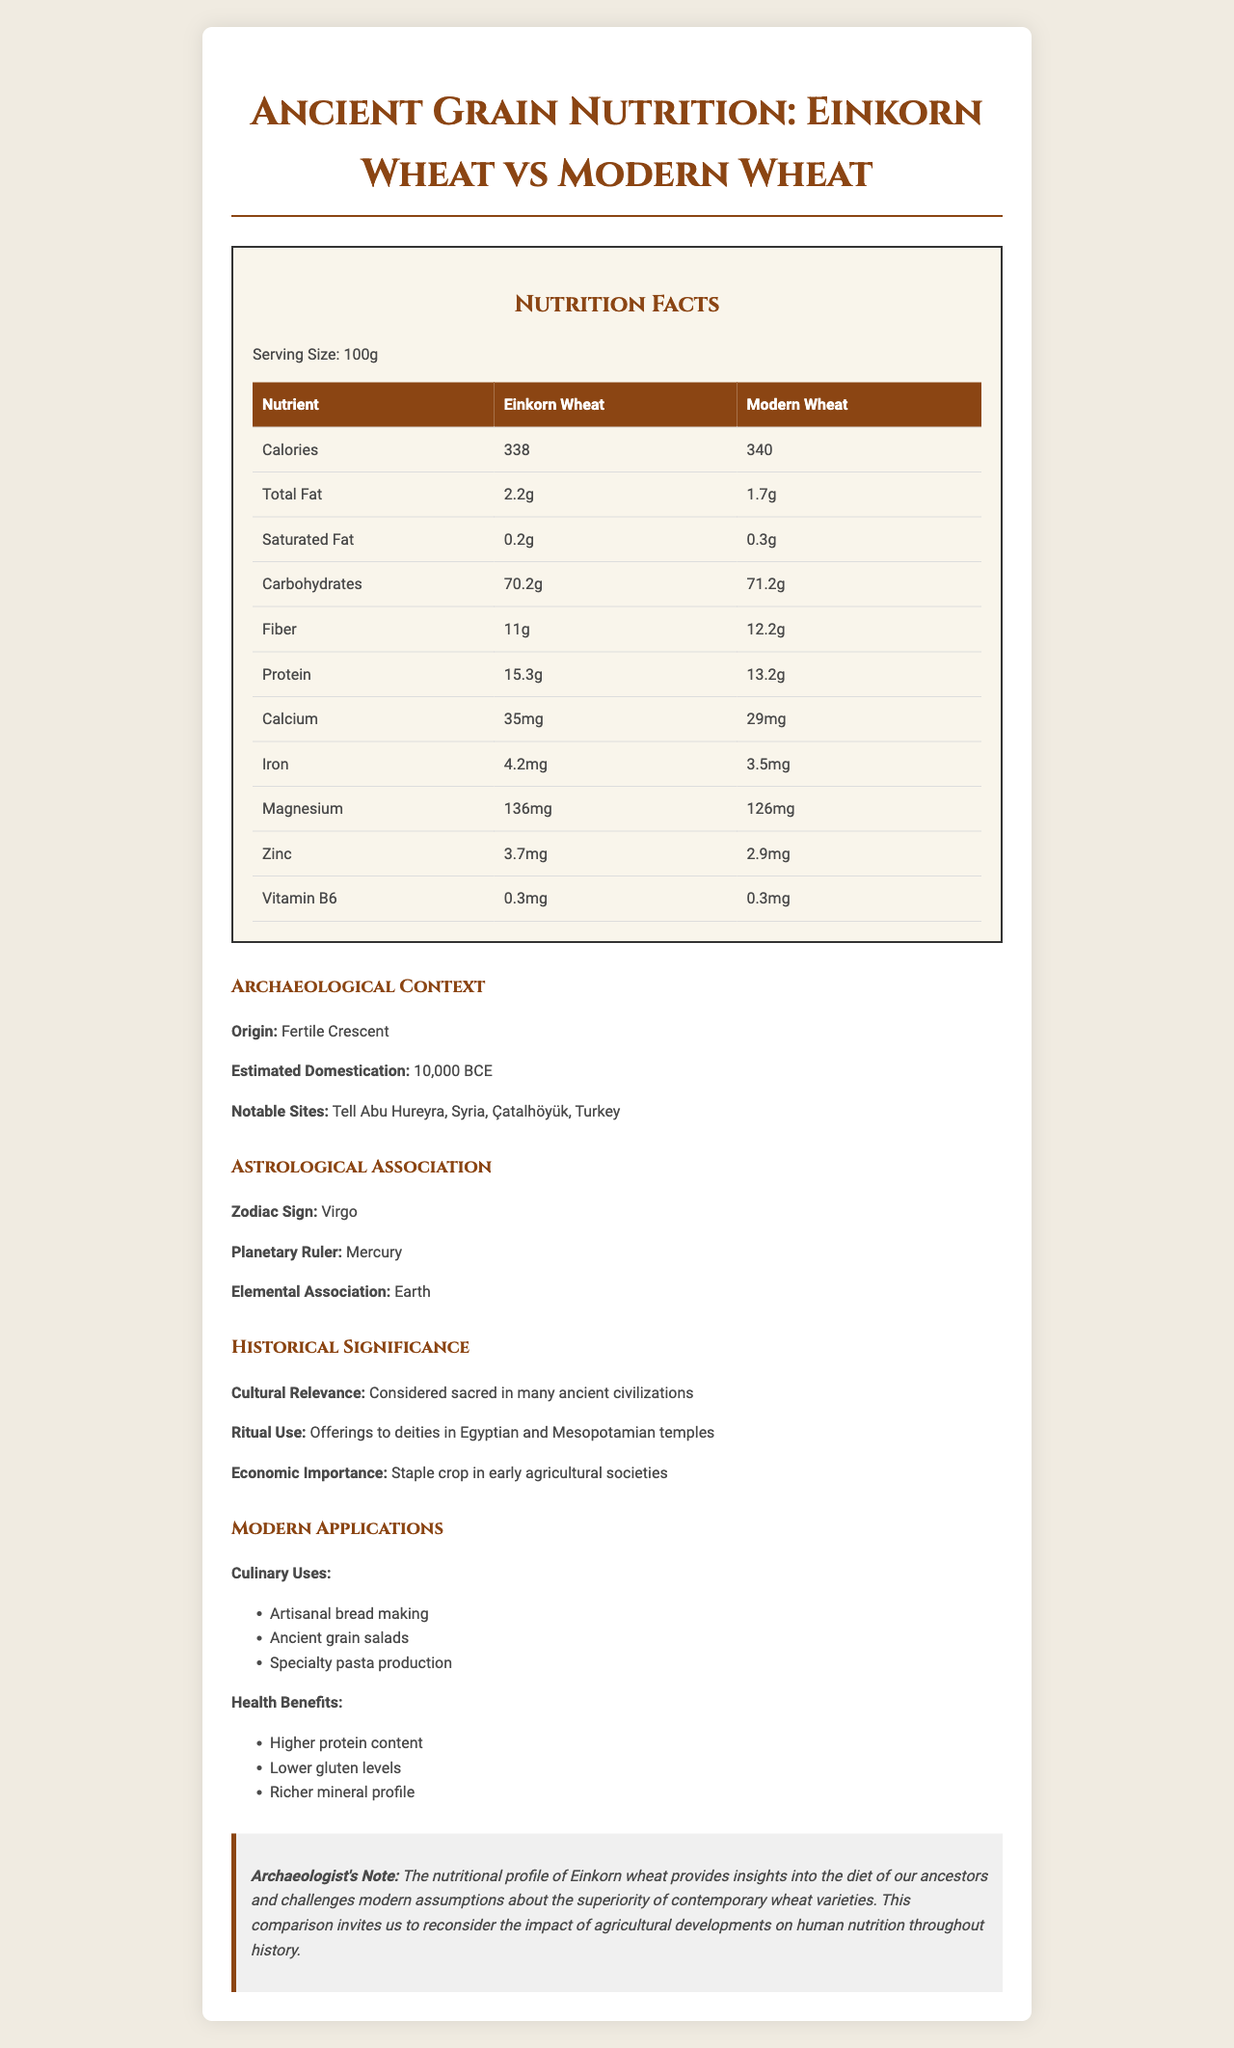what is the serving size for both Einkorn Wheat and Modern Wheat? The document specifies that the serving size for both Einkorn Wheat and Modern Wheat is 100 grams.
Answer: 100g Which type of wheat has a higher protein content? The nutritional comparison table in the document indicates that Einkorn Wheat has a higher protein content (15.3g) compared to Modern Wheat (13.2g).
Answer: Einkorn Wheat how many more grams of fiber does modern wheat have compared to einkorn wheat? The document shows that Modern Wheat has 12.2g of fiber per 100g, while Einkorn Wheat has 11g, a difference of 1.2g.
Answer: 1.2g more name two notable archaeological sites associated with the origin of einkorn wheat. The archaeological context section lists these sites as notable locations.
Answer: Tell Abu Hureyra, Syria and Çatalhöyük, Turkey what is the elemental association of einkorn wheat according to its astrological interpretation? The astrological association section mentions that the elemental association of Einkorn Wheat is Earth.
Answer: Earth Which grain has higher magnesium content, and how much more does it contain? A. Einkorn Wheat B. Modern Wheat According to the nutritional comparison, Einkorn Wheat has 136mg of magnesium while Modern Wheat has 126mg, a difference of 10mg.
Answer: A. Einkorn Wheat Which of the following is a modern culinary use of einkorn wheat? A. Breakfast cereals B. Artisanal bread making C. Meat substitutes The modern applications section lists artisanal bread making as one of the culinary uses of Einkorn Wheat.
Answer: B. Artisanal bread making Is Einkorn Wheat considered sacred in ancient civilizations? The historical significance section states that Einkorn Wheat was considered sacred in many ancient civilizations.
Answer: Yes Summarize the main idea of the document. The document juxtaposes the nutritional benefits of Einkorn Wheat and Modern Wheat while providing extensive background on the ancient grain's archaeological and historical relevance. It emphasizes the need to reconsider the implications of modern agricultural developments on human nutrition.
Answer: The document compares the nutritional values of Einkorn Wheat, an ancient grain, with Modern Wheat. It details the nutritional differences, archaeological context, astrological associations, historical significance, and modern applications, highlighting the superior nutritional profile and historical importance of Einkorn Wheat. Where was einkorn wheat first domesticated? The archaeological context section notes that Einkorn Wheat originated and was first domesticated in the Fertile Crescent.
Answer: Fertile Crescent How much iron is found in modern wheat per 100g serving? The nutritional comparison table shows that Modern Wheat contains 3.5mg of iron per 100g serving.
Answer: 3.5mg Identify one health benefit of Einkorn Wheat according to the document. The modern applications section lists higher protein content as one of the health benefits of Einkorn Wheat.
Answer: Higher protein content What is the planetary ruler of Einkorn Wheat as per its astrological association? The astrological association section specifies that the planetary ruler of Einkorn Wheat is Mercury.
Answer: Mercury How much difference in calories is there between Einkorn Wheat and Modern Wheat? The nutritional comparison section indicates that Einkorn Wheat has 338 calories, while Modern Wheat has 340 calories, a difference of merely 2 calories.
Answer: 2 calories What were the ritual uses of Einkorn Wheat in ancient times? The historical significance section states that Einkorn Wheat was used as offerings to deities in Egyptian and Mesopotamian temples.
Answer: Offerings to deities in Egyptian and Mesopotamian temples How does the elemental association of Einkorn Wheat influence its interpretation in astrology? The document does not provide any explanation on how the elemental association of Earth influences the astrological interpretation of Einkorn Wheat.
Answer: Cannot be determined 